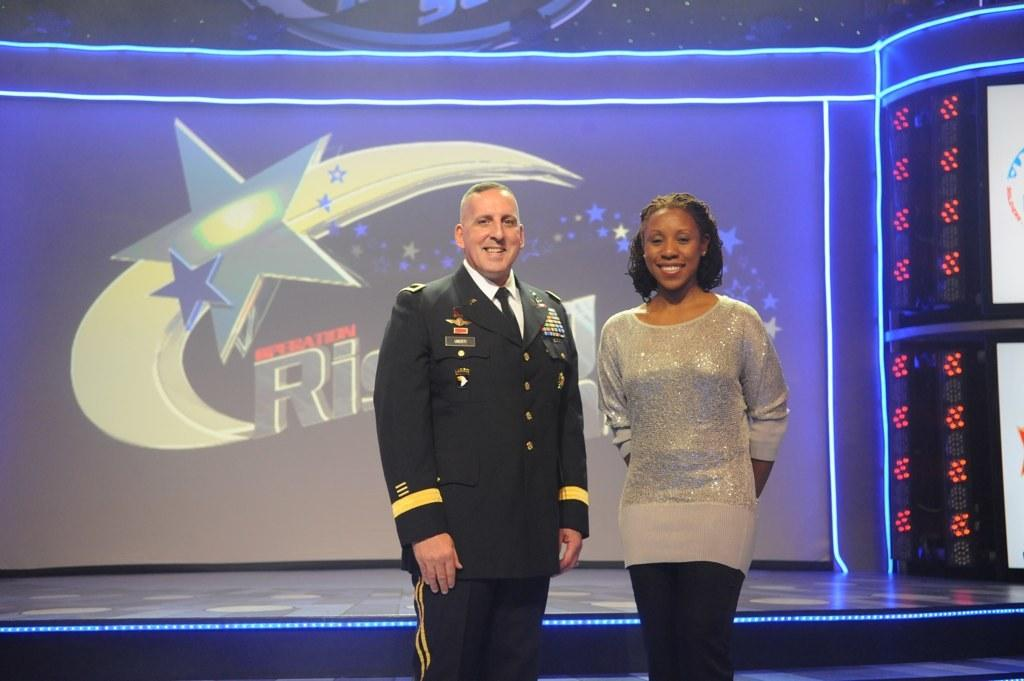How many people are on the stage in the image? There are 2 people standing on the stage. What are the people on the stage doing? The people are looking and smiling at someone. What can be seen in the background of the image? There are lights, stars, the moon, and some text displayed in the background. What type of bird is flying across the stage in the image? There is no bird flying across the stage in the image. What kind of produce is being displayed on the stage? There is no produce present on the stage in the image. 